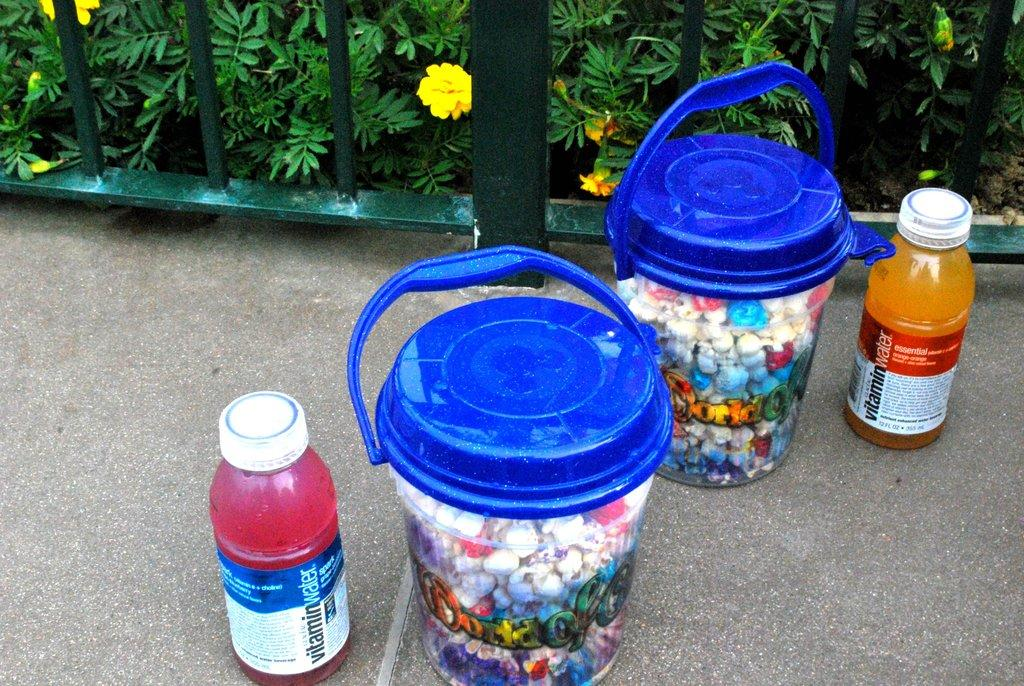<image>
Share a concise interpretation of the image provided. blue topped canisters next to two Vitamin Water bottles on the ground 